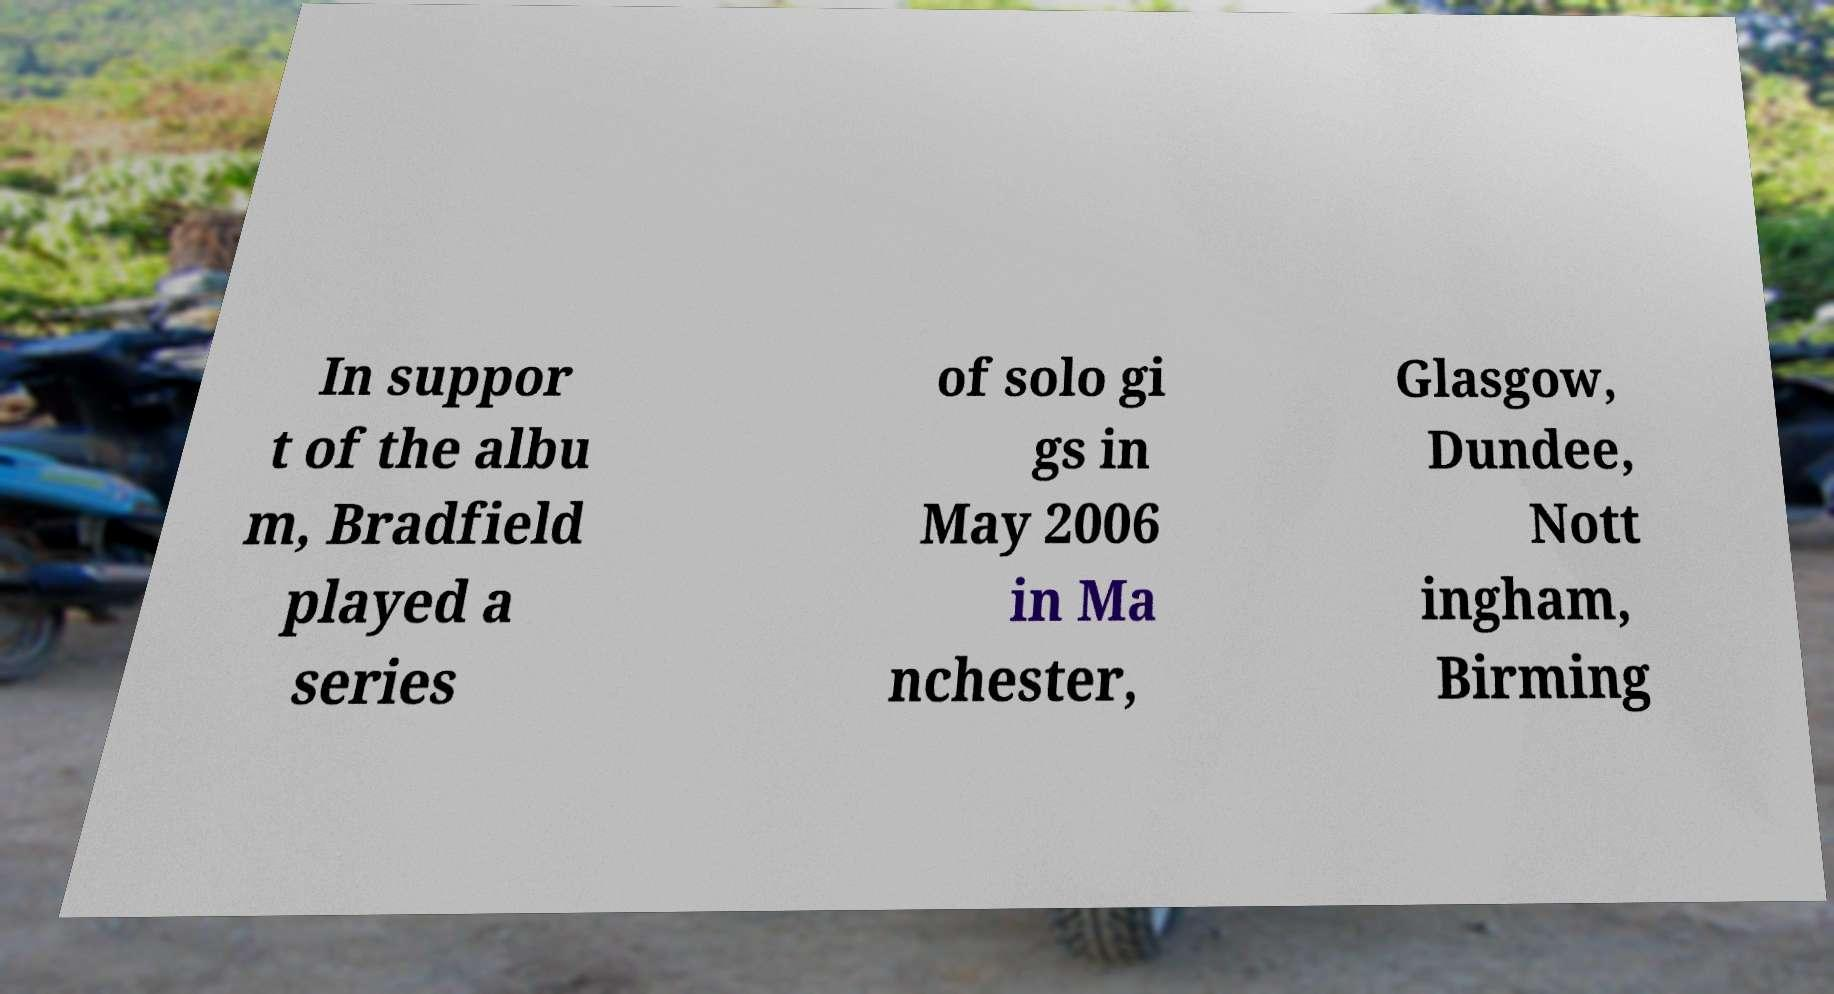For documentation purposes, I need the text within this image transcribed. Could you provide that? In suppor t of the albu m, Bradfield played a series of solo gi gs in May 2006 in Ma nchester, Glasgow, Dundee, Nott ingham, Birming 